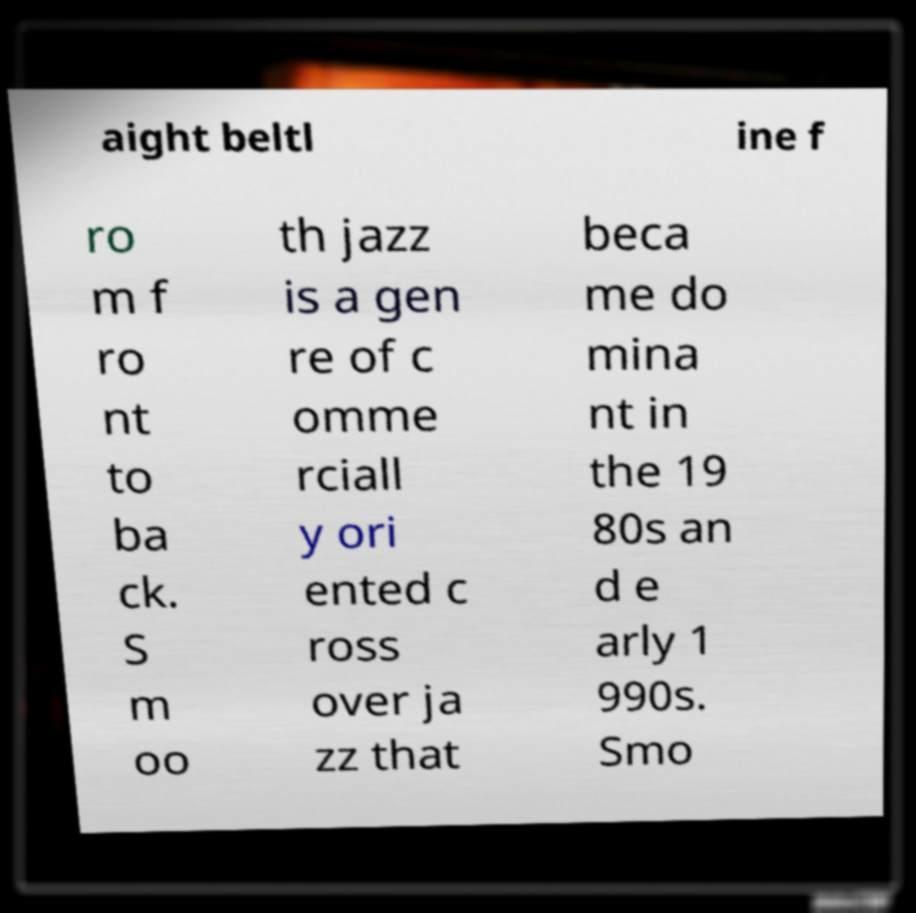For documentation purposes, I need the text within this image transcribed. Could you provide that? aight beltl ine f ro m f ro nt to ba ck. S m oo th jazz is a gen re of c omme rciall y ori ented c ross over ja zz that beca me do mina nt in the 19 80s an d e arly 1 990s. Smo 